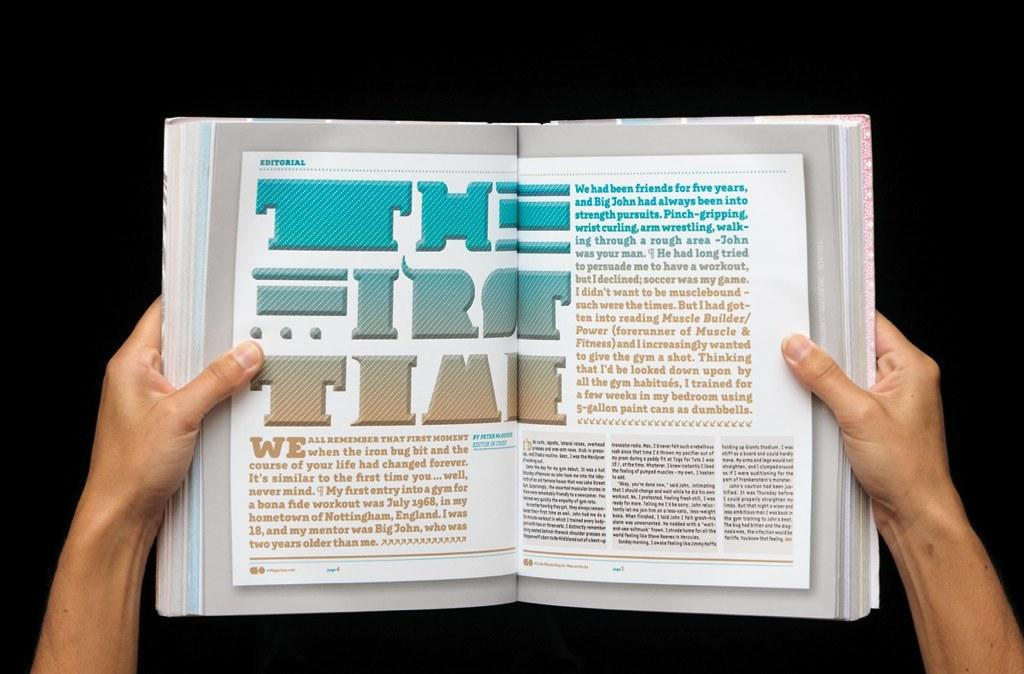Provide a one-sentence caption for the provided image. a book that is open to a page with the word time on it. 